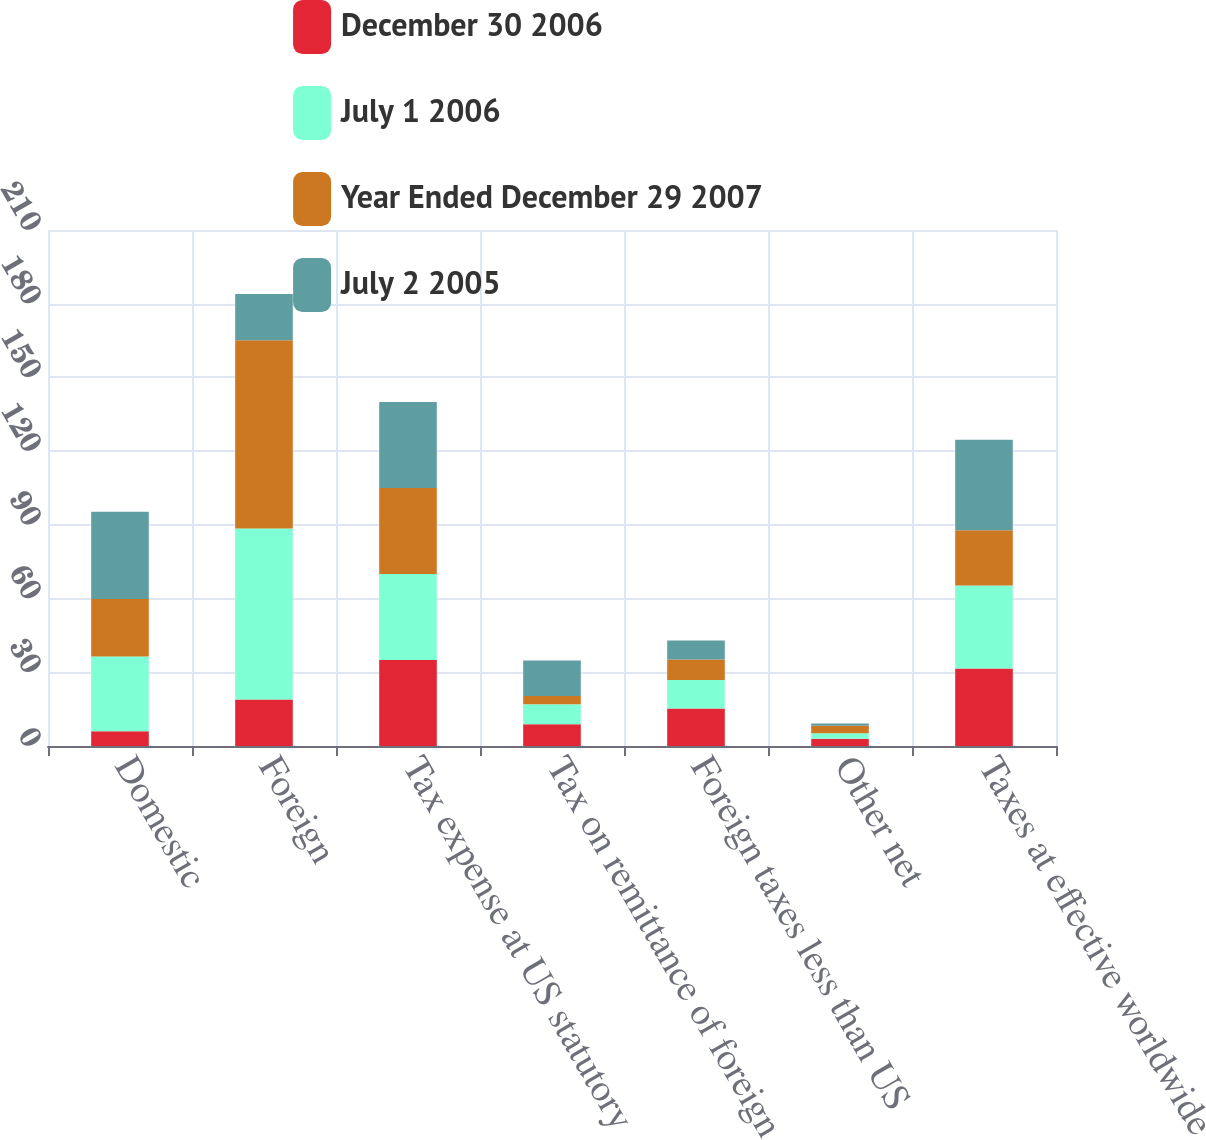Convert chart to OTSL. <chart><loc_0><loc_0><loc_500><loc_500><stacked_bar_chart><ecel><fcel>Domestic<fcel>Foreign<fcel>Tax expense at US statutory<fcel>Tax on remittance of foreign<fcel>Foreign taxes less than US<fcel>Other net<fcel>Taxes at effective worldwide<nl><fcel>December 30 2006<fcel>6<fcel>18.9<fcel>35<fcel>8.9<fcel>15.3<fcel>2.9<fcel>31.5<nl><fcel>July 1 2006<fcel>30.4<fcel>69.6<fcel>35<fcel>8.1<fcel>11.6<fcel>2.3<fcel>33.8<nl><fcel>Year Ended December 29 2007<fcel>23.4<fcel>76.6<fcel>35<fcel>3.3<fcel>8.3<fcel>3<fcel>22.5<nl><fcel>July 2 2005<fcel>35.5<fcel>18.9<fcel>35<fcel>14.5<fcel>7.7<fcel>1<fcel>36.8<nl></chart> 